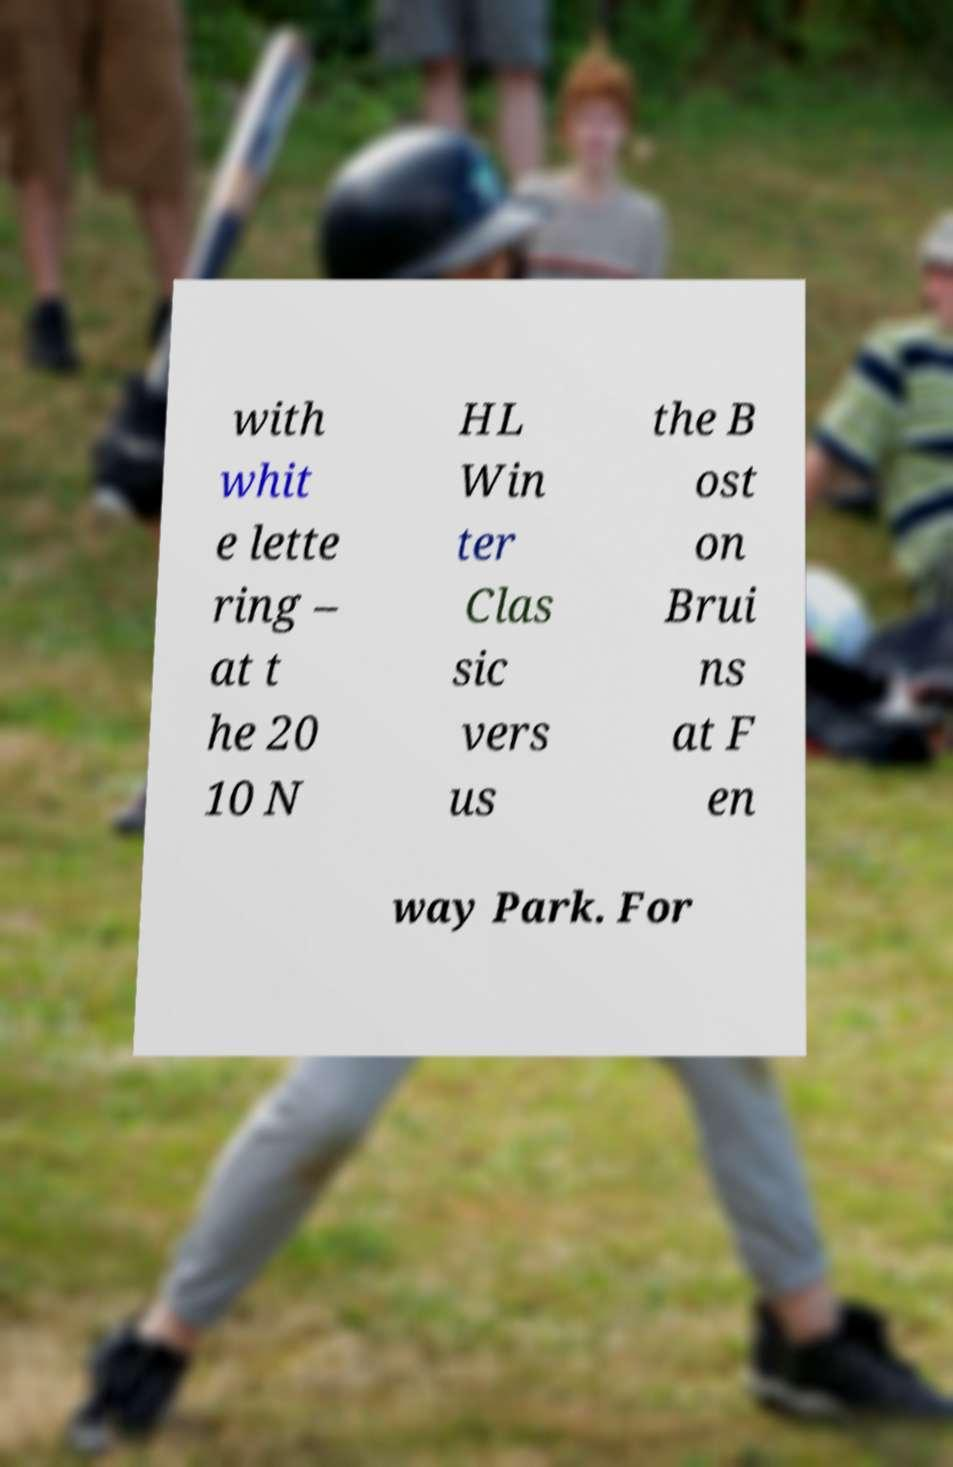I need the written content from this picture converted into text. Can you do that? with whit e lette ring – at t he 20 10 N HL Win ter Clas sic vers us the B ost on Brui ns at F en way Park. For 